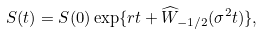<formula> <loc_0><loc_0><loc_500><loc_500>S ( t ) = S ( 0 ) \exp \{ r t + \widehat { W } _ { - 1 / 2 } ( \sigma ^ { 2 } t ) \} ,</formula> 